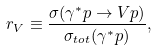Convert formula to latex. <formula><loc_0><loc_0><loc_500><loc_500>r _ { V } \equiv \frac { \sigma ( \gamma ^ { * } p \to V p ) } { \sigma _ { t o t } ( \gamma ^ { * } p ) } ,</formula> 